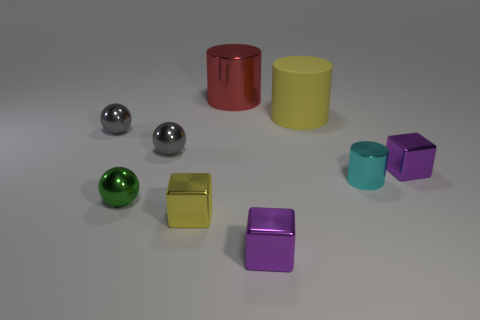Subtract all cylinders. How many objects are left? 6 Subtract all red metallic cylinders. Subtract all yellow matte things. How many objects are left? 7 Add 3 small green spheres. How many small green spheres are left? 4 Add 6 blue metal blocks. How many blue metal blocks exist? 6 Subtract 2 purple blocks. How many objects are left? 7 